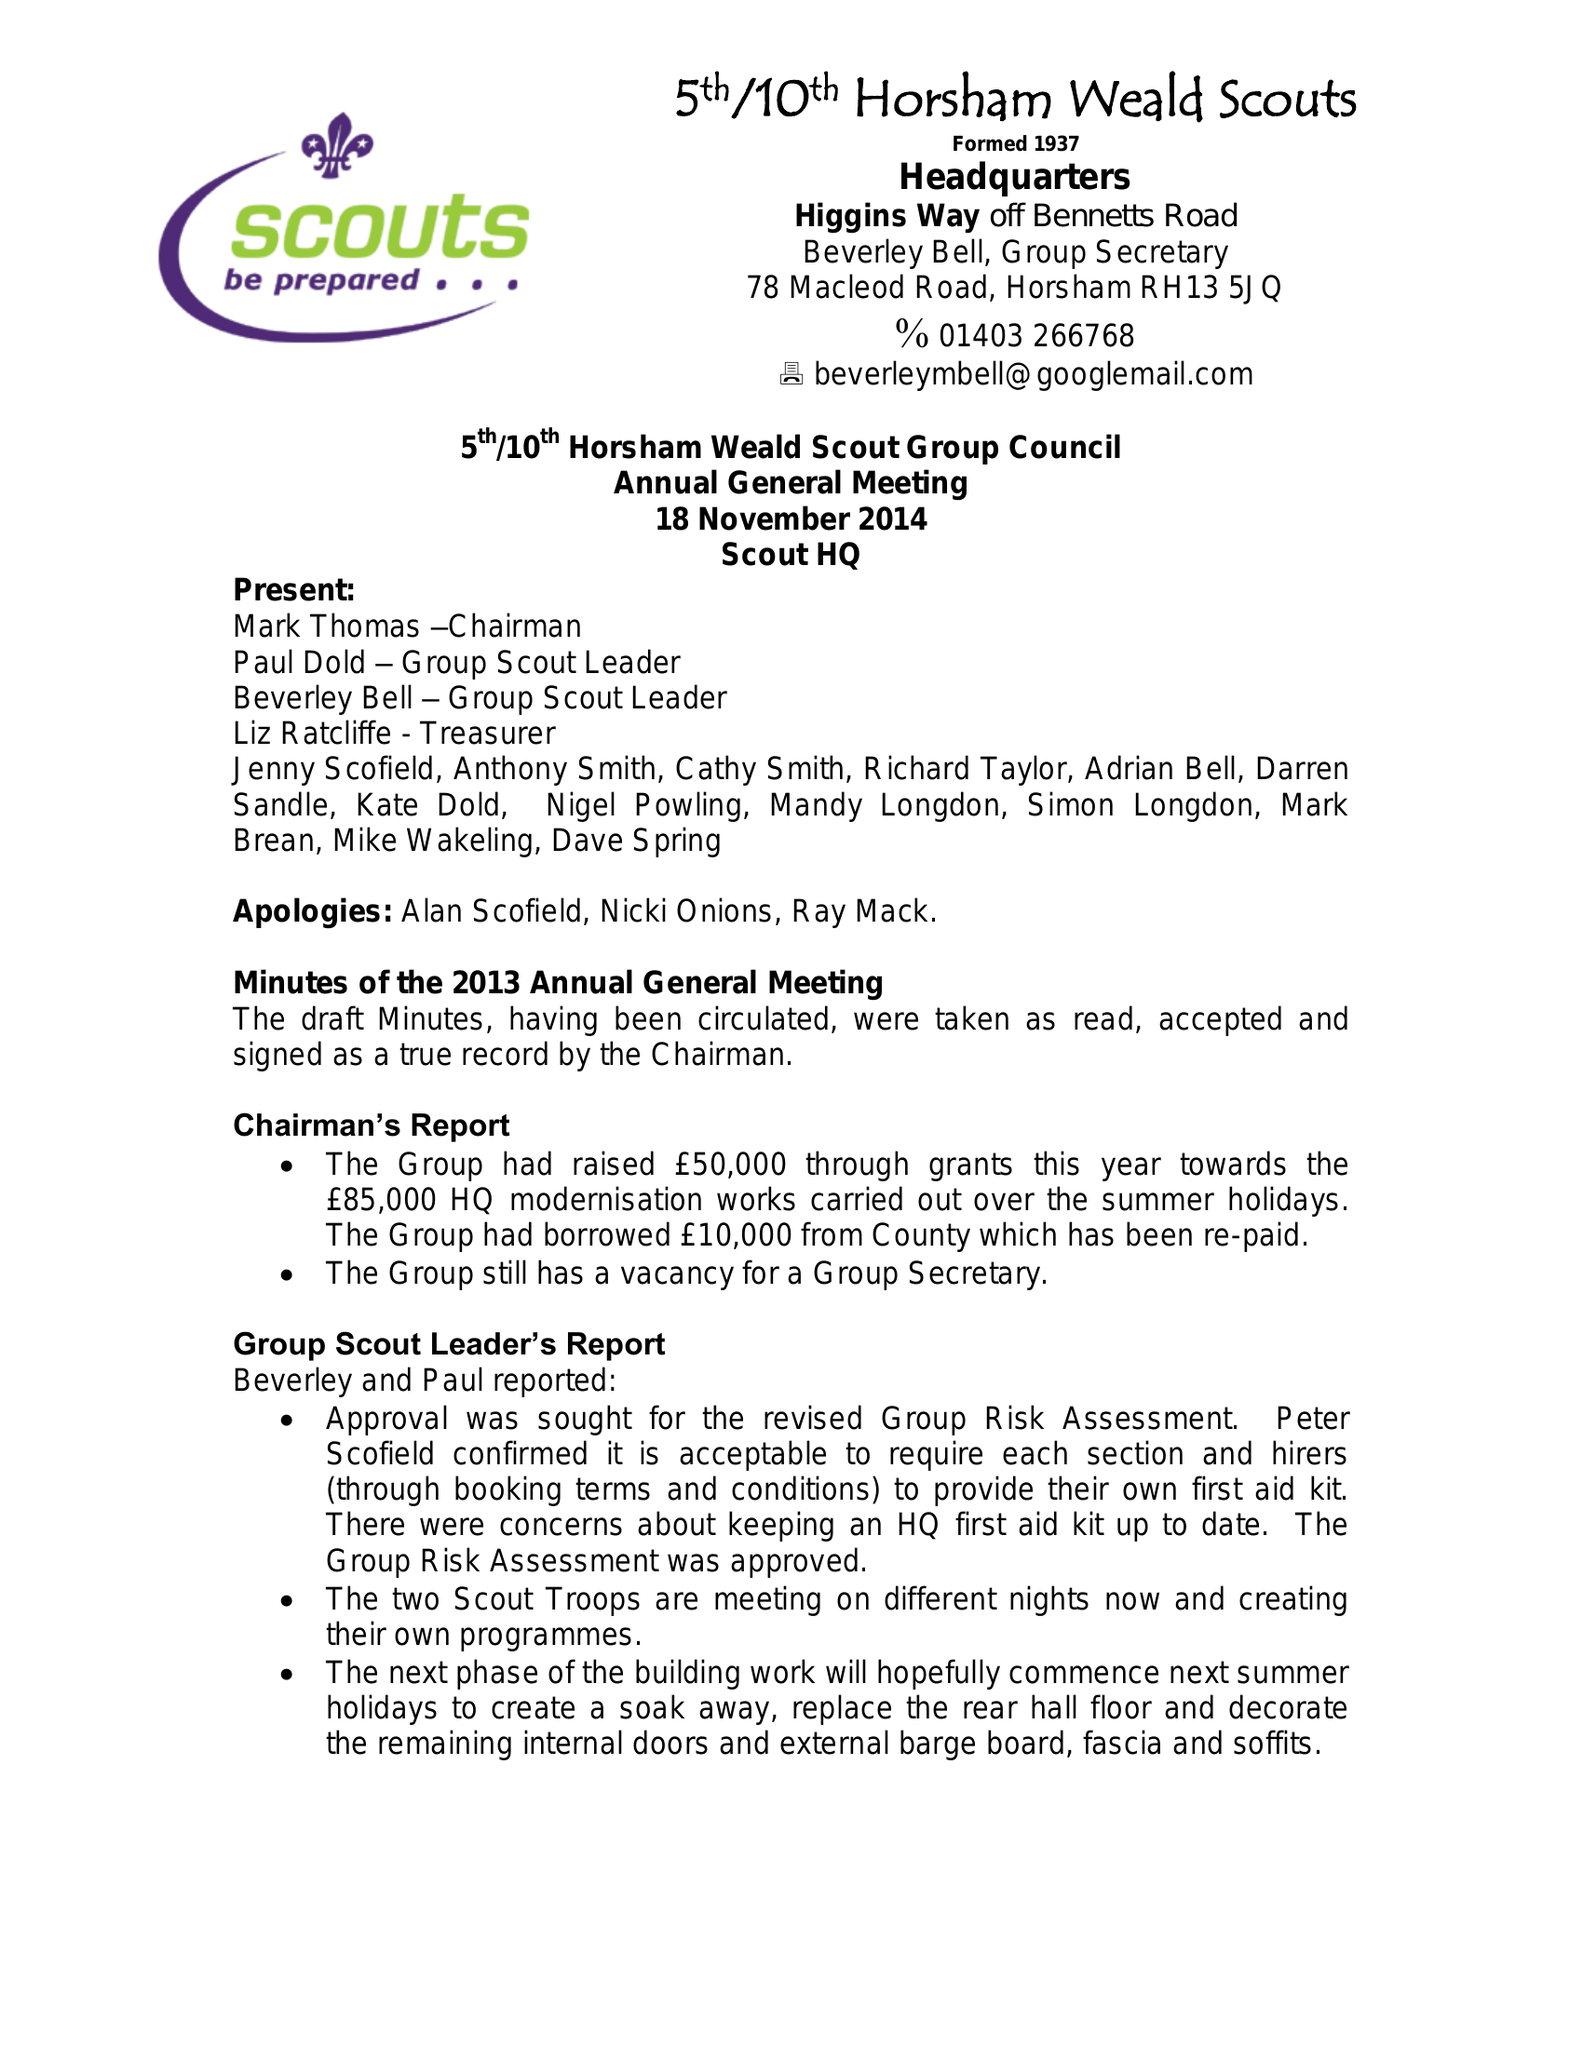What is the value for the income_annually_in_british_pounds?
Answer the question using a single word or phrase. 44864.28 